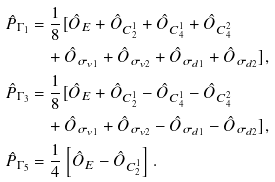<formula> <loc_0><loc_0><loc_500><loc_500>\hat { P } _ { \Gamma _ { 1 } } & = \frac { 1 } { 8 } [ \hat { O } _ { E } + \hat { O } _ { C _ { 2 } ^ { 1 } } + \hat { O } _ { C _ { 4 } ^ { 1 } } + \hat { O } _ { C _ { 4 } ^ { 2 } } \\ & \quad + \hat { O } _ { \sigma _ { v 1 } } + \hat { O } _ { \sigma _ { v 2 } } + \hat { O } _ { \sigma _ { d 1 } } + \hat { O } _ { \sigma _ { d 2 } } ] , \\ \hat { P } _ { \Gamma _ { 3 } } & = \frac { 1 } { 8 } [ \hat { O } _ { E } + \hat { O } _ { C _ { 2 } ^ { 1 } } - \hat { O } _ { C _ { 4 } ^ { 1 } } - \hat { O } _ { C _ { 4 } ^ { 2 } } \\ & \quad + \hat { O } _ { \sigma _ { v 1 } } + \hat { O } _ { \sigma _ { v 2 } } - \hat { O } _ { \sigma _ { d 1 } } - \hat { O } _ { \sigma _ { d 2 } } ] , \\ \hat { P } _ { \Gamma _ { 5 } } & = \frac { 1 } { 4 } \left [ \hat { O } _ { E } - \hat { O } _ { C _ { 2 } ^ { 1 } } \right ] .</formula> 